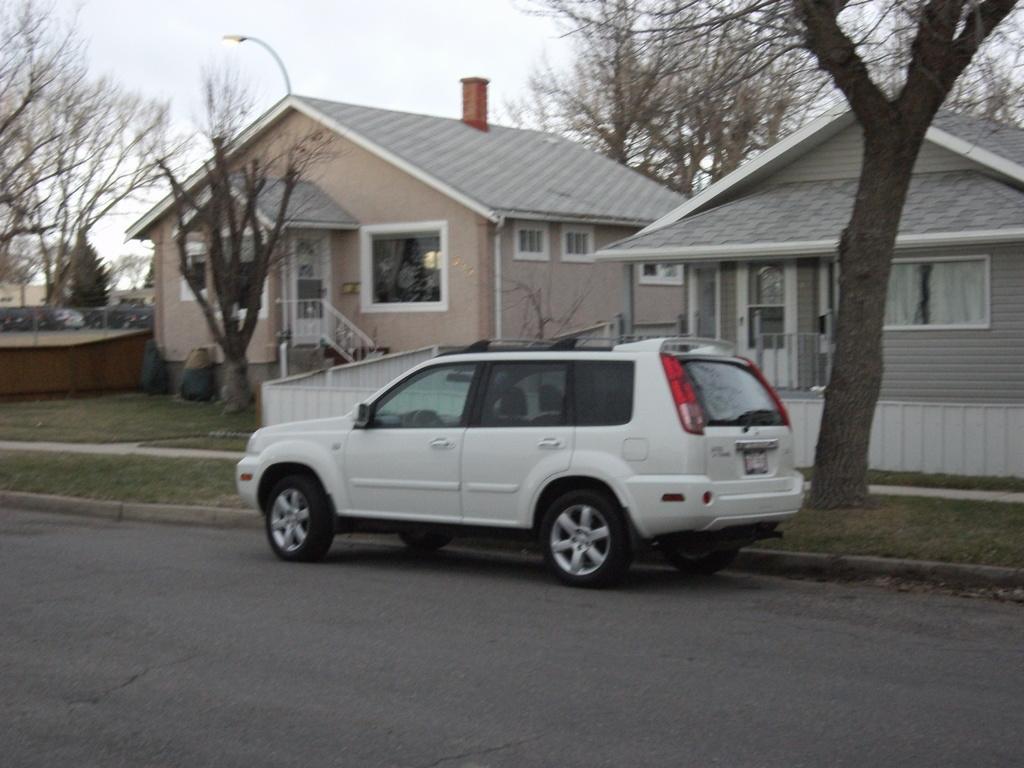Could you give a brief overview of what you see in this image? In this image I can see the road, a car which is white in color and few trees. I can see few buildings which are cream and grey in color and in the background I can see the sky. 